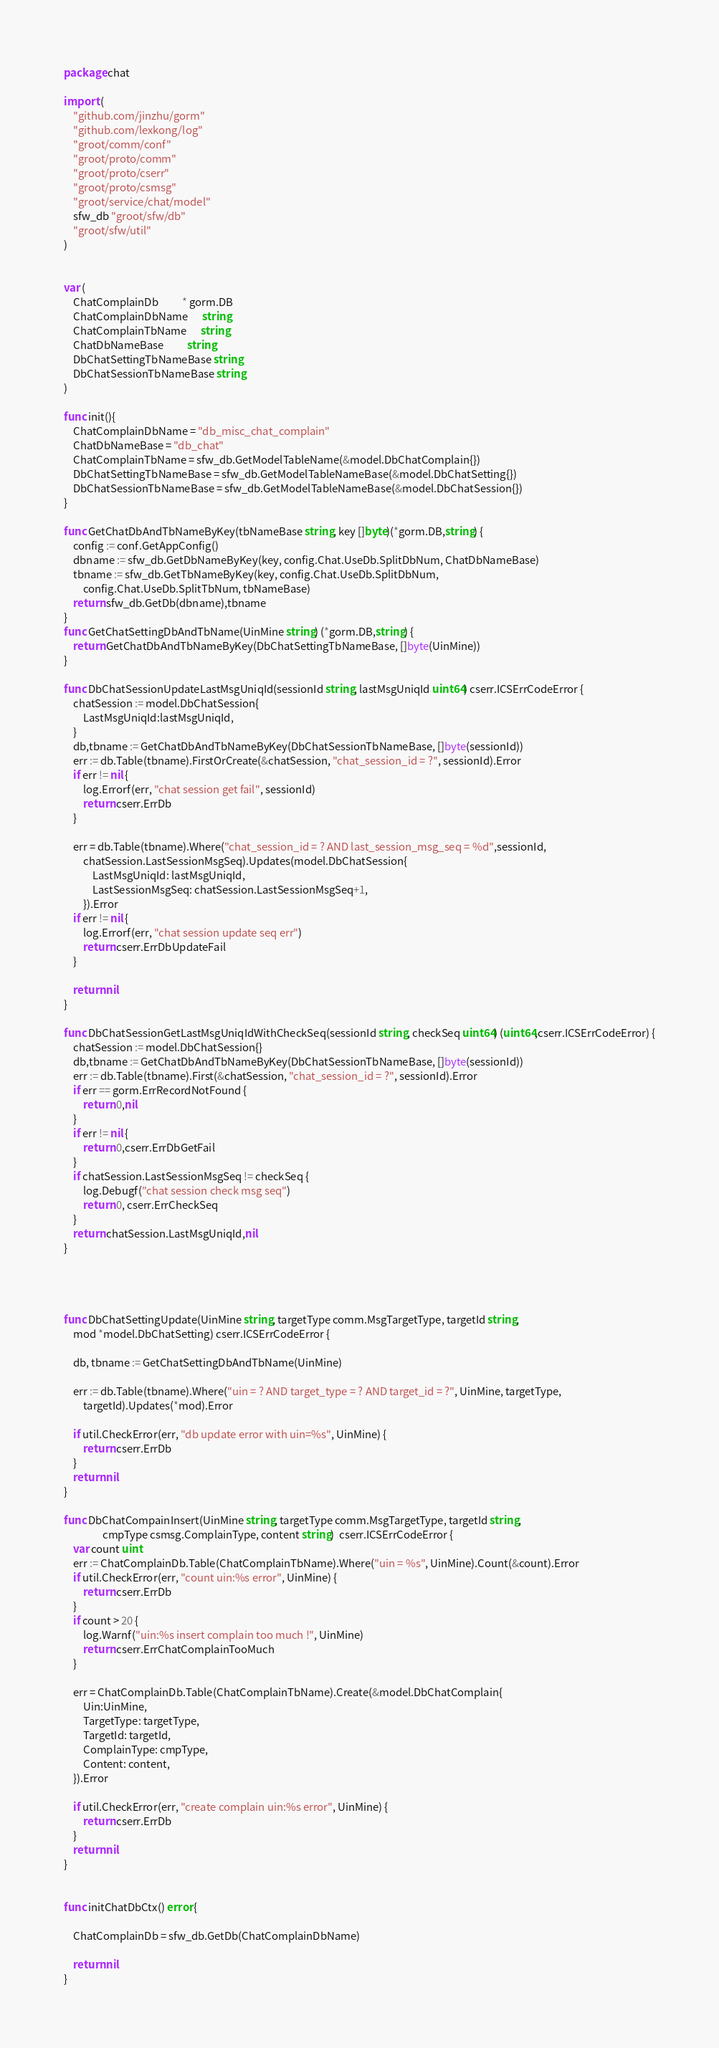Convert code to text. <code><loc_0><loc_0><loc_500><loc_500><_Go_>package chat

import (
	"github.com/jinzhu/gorm"
	"github.com/lexkong/log"
	"groot/comm/conf"
	"groot/proto/comm"
	"groot/proto/cserr"
	"groot/proto/csmsg"
	"groot/service/chat/model"
	sfw_db "groot/sfw/db"
	"groot/sfw/util"
)


var (
	ChatComplainDb          * gorm.DB
	ChatComplainDbName      string
	ChatComplainTbName      string
	ChatDbNameBase          string
	DbChatSettingTbNameBase string
	DbChatSessionTbNameBase string
)

func init(){
	ChatComplainDbName = "db_misc_chat_complain"
	ChatDbNameBase = "db_chat"
	ChatComplainTbName = sfw_db.GetModelTableName(&model.DbChatComplain{})
	DbChatSettingTbNameBase = sfw_db.GetModelTableNameBase(&model.DbChatSetting{})
	DbChatSessionTbNameBase = sfw_db.GetModelTableNameBase(&model.DbChatSession{})
}

func GetChatDbAndTbNameByKey(tbNameBase string, key []byte)(*gorm.DB,string) {
	config := conf.GetAppConfig()
	dbname := sfw_db.GetDbNameByKey(key, config.Chat.UseDb.SplitDbNum, ChatDbNameBase)
	tbname := sfw_db.GetTbNameByKey(key, config.Chat.UseDb.SplitDbNum,
		config.Chat.UseDb.SplitTbNum, tbNameBase)
	return sfw_db.GetDb(dbname),tbname
}
func GetChatSettingDbAndTbName(UinMine string) (*gorm.DB,string) {
	return GetChatDbAndTbNameByKey(DbChatSettingTbNameBase, []byte(UinMine))
}

func DbChatSessionUpdateLastMsgUniqId(sessionId string, lastMsgUniqId uint64) cserr.ICSErrCodeError {
	chatSession := model.DbChatSession{
		LastMsgUniqId:lastMsgUniqId,
	}
	db,tbname := GetChatDbAndTbNameByKey(DbChatSessionTbNameBase, []byte(sessionId))
	err := db.Table(tbname).FirstOrCreate(&chatSession, "chat_session_id = ?", sessionId).Error
	if err != nil {
		log.Errorf(err, "chat session get fail", sessionId)
		return cserr.ErrDb
	}

	err = db.Table(tbname).Where("chat_session_id = ? AND last_session_msg_seq = %d",sessionId,
		chatSession.LastSessionMsgSeq).Updates(model.DbChatSession{
			LastMsgUniqId: lastMsgUniqId,
			LastSessionMsgSeq: chatSession.LastSessionMsgSeq+1,
		}).Error
	if err != nil {
		log.Errorf(err, "chat session update seq err")
		return cserr.ErrDbUpdateFail
	}

	return nil
}

func DbChatSessionGetLastMsgUniqIdWithCheckSeq(sessionId string, checkSeq uint64) (uint64,cserr.ICSErrCodeError) {
	chatSession := model.DbChatSession{}
	db,tbname := GetChatDbAndTbNameByKey(DbChatSessionTbNameBase, []byte(sessionId))
	err := db.Table(tbname).First(&chatSession, "chat_session_id = ?", sessionId).Error
	if err == gorm.ErrRecordNotFound {
		return 0,nil
	}
	if err != nil {
		return 0,cserr.ErrDbGetFail
	}
	if chatSession.LastSessionMsgSeq != checkSeq {
		log.Debugf("chat session check msg seq")
		return 0, cserr.ErrCheckSeq
	}
	return chatSession.LastMsgUniqId,nil
}




func DbChatSettingUpdate(UinMine string, targetType comm.MsgTargetType, targetId string,
	mod *model.DbChatSetting) cserr.ICSErrCodeError {

	db, tbname := GetChatSettingDbAndTbName(UinMine)

	err := db.Table(tbname).Where("uin = ? AND target_type = ? AND target_id = ?", UinMine, targetType,
		targetId).Updates(*mod).Error

	if util.CheckError(err, "db update error with uin=%s", UinMine) {
		return cserr.ErrDb
	}
	return nil
}

func DbChatCompainInsert(UinMine string, targetType comm.MsgTargetType, targetId string,
				cmpType csmsg.ComplainType, content string)  cserr.ICSErrCodeError {
	var count uint
	err := ChatComplainDb.Table(ChatComplainTbName).Where("uin = %s", UinMine).Count(&count).Error
	if util.CheckError(err, "count uin:%s error", UinMine) {
		return cserr.ErrDb
	}
	if count > 20 {
		log.Warnf("uin:%s insert complain too much !", UinMine)
		return cserr.ErrChatComplainTooMuch
	}

	err = ChatComplainDb.Table(ChatComplainTbName).Create(&model.DbChatComplain{
		Uin:UinMine,
		TargetType: targetType,
		TargetId: targetId,
		ComplainType: cmpType,
		Content: content,
	}).Error

	if util.CheckError(err, "create complain uin:%s error", UinMine) {
		return cserr.ErrDb
	}
	return nil
}


func initChatDbCtx() error {

	ChatComplainDb = sfw_db.GetDb(ChatComplainDbName)

	return nil
}</code> 